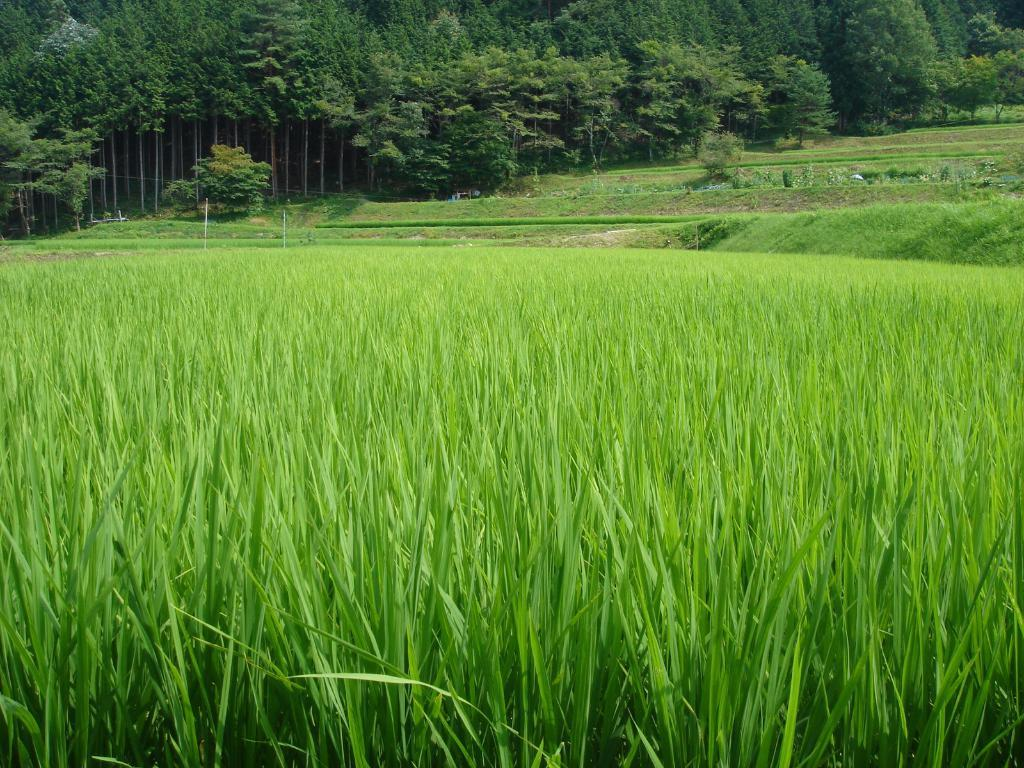What type of landscape is depicted in the image? The image features fields. Are there any other natural elements visible in the image? Yes, there are trees visible at the top of the image. How many chairs can be seen in the image? There are no chairs present in the image. What type of pain is being experienced by the trees in the image? There is no indication of pain or any other emotional state for the trees in the image, as they are inanimate objects. 